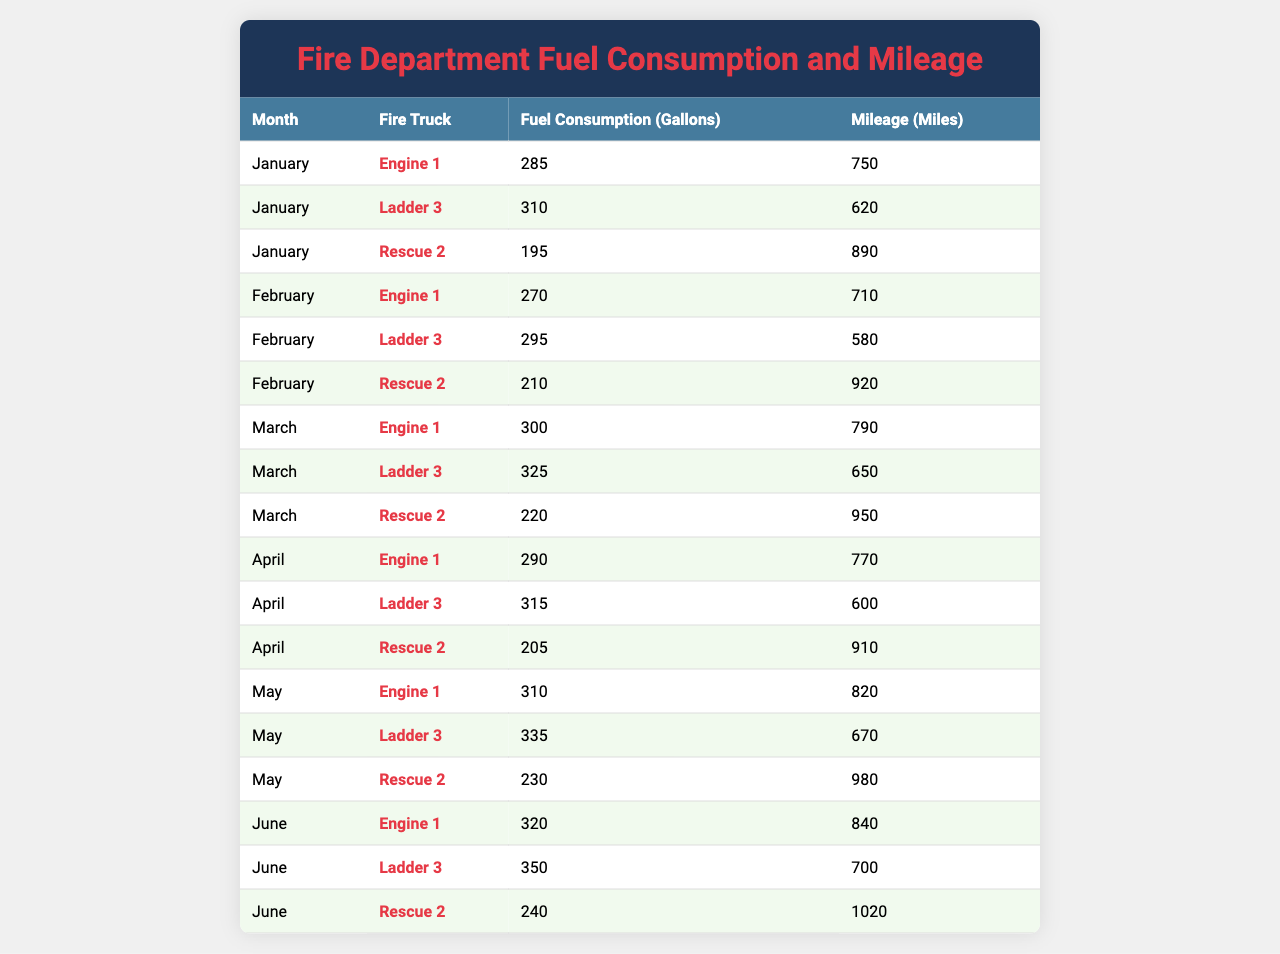What is the fuel consumption of Engine 1 in March? According to the table, the fuel consumption of Engine 1 is listed directly under the row for March, which shows 300 gallons.
Answer: 300 gallons Which fire truck had the highest mileage in June? In June, the table shows the mileage for each fire truck. Rescue 2 has the highest mileage at 1020 miles, compared to Engine 1 and Ladder 3.
Answer: Rescue 2 What is the total fuel consumption for all fire trucks in May? For May, the table lists the fuel consumption as follows: Engine 1 - 310 gallons, Ladder 3 - 335 gallons, and Rescue 2 - 230 gallons. Adding these gives 310 + 335 + 230 = 875 gallons.
Answer: 875 gallons Is the fuel consumption for Ladder 3 in April greater than in February? The table shows Ladder 3's fuel consumption in April as 315 gallons and in February as 295 gallons. Since 315 is greater than 295, the statement is true.
Answer: Yes What is the average mileage for Rescue 2 across the months? The table shows the following mileages for Rescue 2: 890 in January, 920 in February, 950 in March, 910 in April, 980 in May, and 1020 in June. To find the average, sum these values (890 + 920 + 950 + 910 + 980 + 1020 = 5670) and divide by 6, which gives 5670 / 6 = 945 miles.
Answer: 945 miles Which month saw the lowest fuel consumption for any fire truck? By looking through the table, the lowest fuel consumption occurs in January, where Rescue 2 consumed only 195 gallons.
Answer: January What is the difference in fuel consumption between Ladder 3 in May and June? The table shows Ladder 3 used 335 gallons in May and 350 gallons in June. Calculating the difference gives 350 - 335 = 15 gallons.
Answer: 15 gallons What was the average fuel consumption for Engine 1 over the six months? The fuel consumption for Engine 1 is: 285, 270, 300, 290, 310, and 320 gallons. Summing these values gives 285 + 270 + 300 + 290 + 310 + 320 = 1775. Divide by 6 to find the average: 1775 / 6 = 295.83, which rounds to approximately 296 gallons.
Answer: 296 gallons Did Engine 1 consume more fuel than Rescue 2 in April? The table shows Engine 1 consumed 290 gallons in April, while Rescue 2 consumed 205 gallons. Since 290 is greater than 205, Engine 1 did consume more fuel.
Answer: Yes How many miles did Ladder 3 travel in total across all months? The mileage for Ladder 3 across the months is: 620 in January, 580 in February, 650 in March, 600 in April, 670 in May, and 700 in June. Summing these gives 620 + 580 + 650 + 600 + 670 + 700 = 4020 miles.
Answer: 4020 miles 